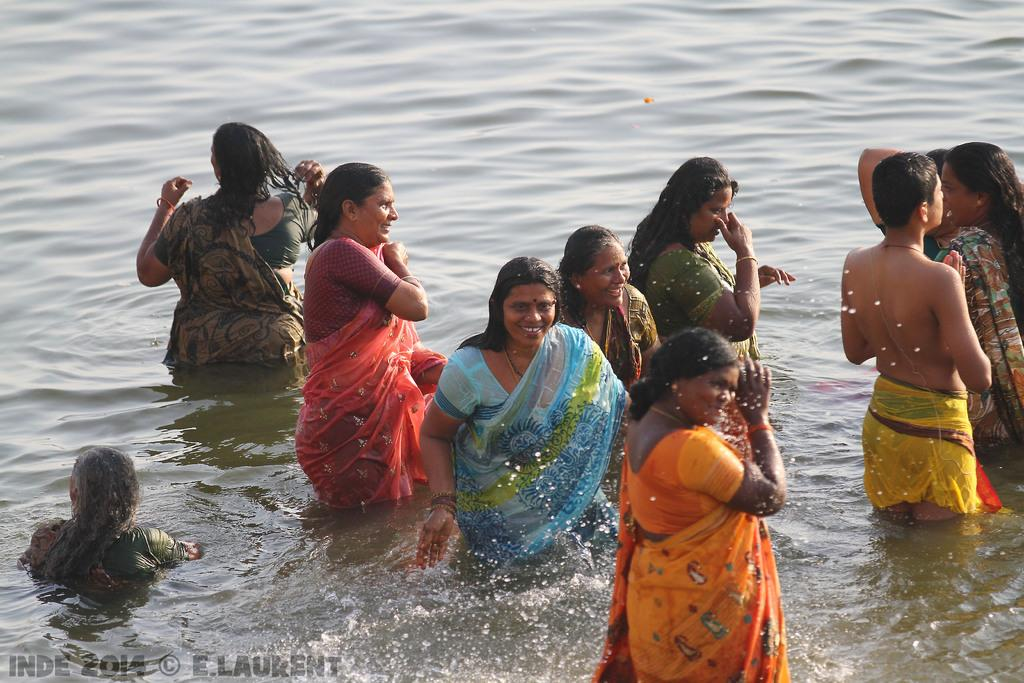What are the people in the image doing? The people in the image are in the water. Can you describe any additional features of the image? There is a watermark on the bottom left side of the picture. What type of reward can be seen in the image? There is no reward present in the image; it features people in the water and a watermark on the bottom left side of the picture. 